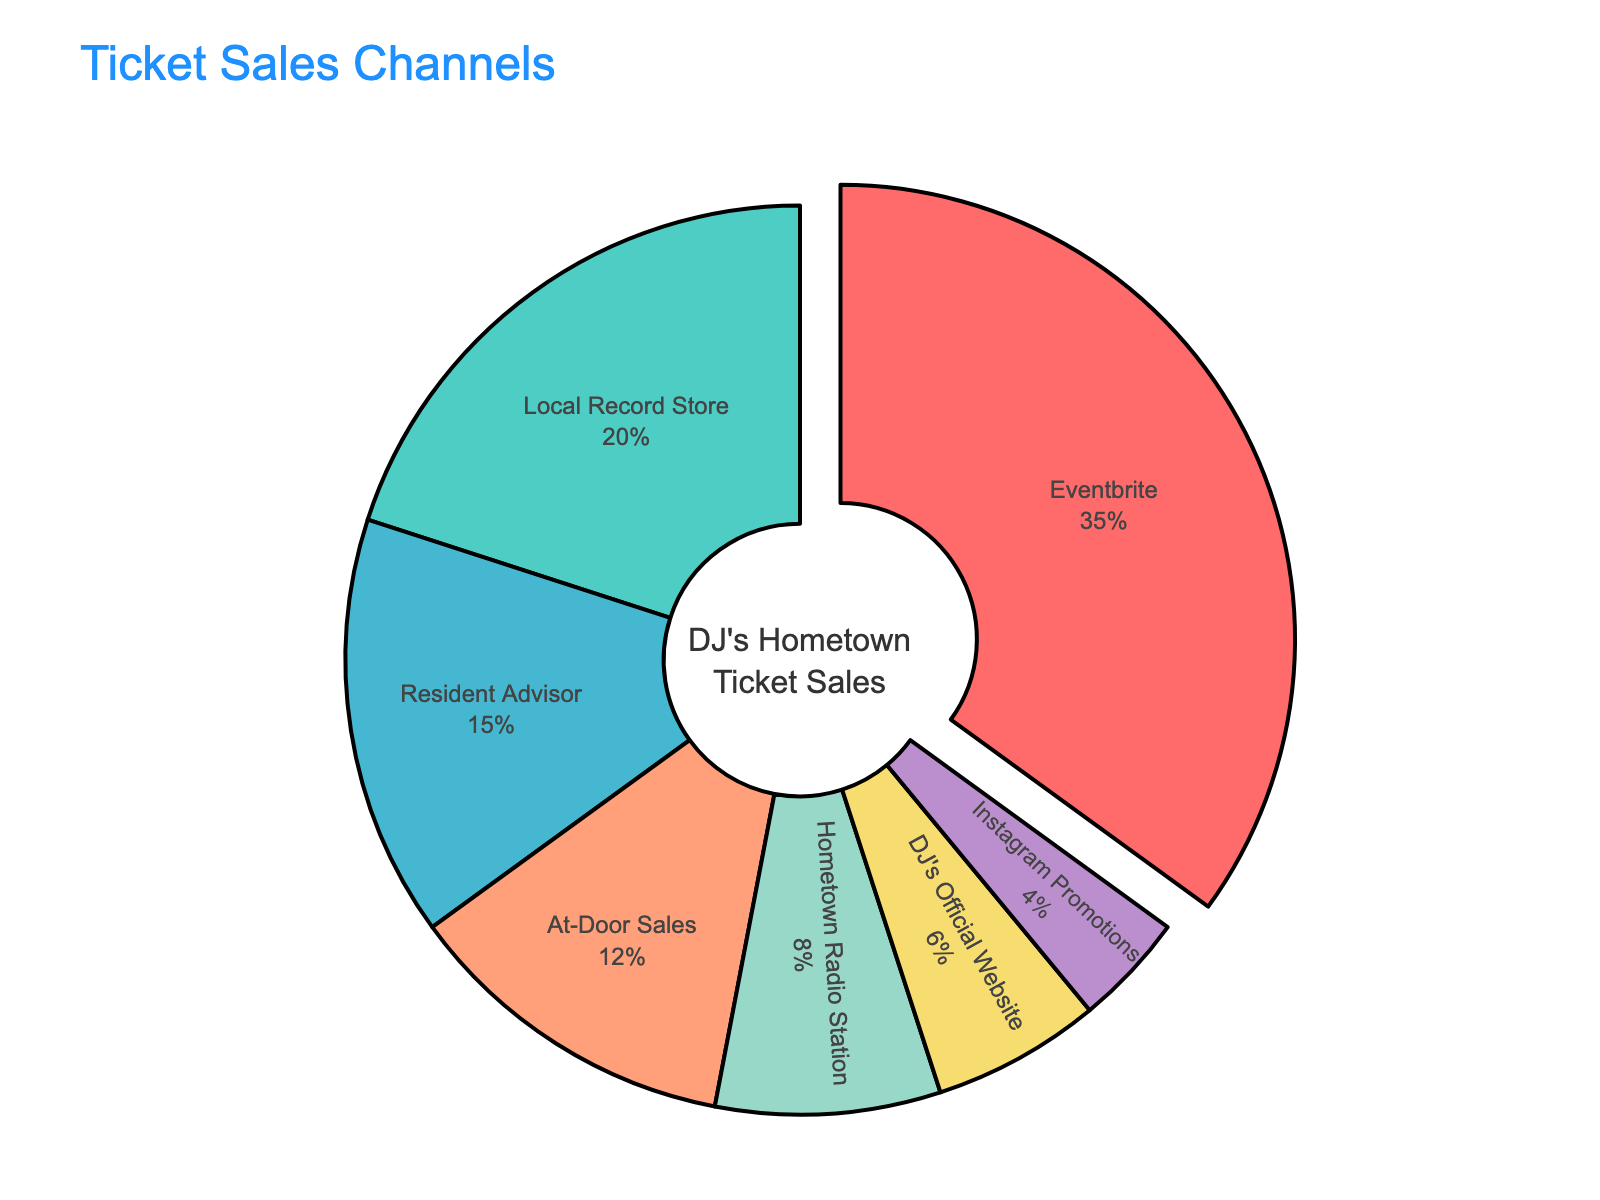What's the most popular ticket sales channel? By looking at the pie chart, the segment representing Eventbrite is the largest, indicating it has the highest percentage of sales.
Answer: Eventbrite What is the combined percentage of ticket sales from Local Record Store and Resident Advisor? The percentage for Local Record Store is 20%, and for Resident Advisor, it is 15%. Adding them together gives 35%.
Answer: 35% Which sales channels have a lower percentage than At-Door Sales? The percentage for At-Door Sales is 12%. The channels with lower percentages are Hometown Radio Station (8%), DJ's Official Website (6%), and Instagram Promotions (4%).
Answer: Hometown Radio Station, DJ's Official Website, Instagram Promotions How much greater is the percentage of sales through Eventbrite compared to Local Record Store? The percentage for Eventbrite is 35%, and for Local Record Store, it is 20%. The difference is 35% - 20% = 15%.
Answer: 15% Rank the sales channels from highest to lowest percentage. The percentages in descending order are: Eventbrite (35%), Local Record Store (20%), Resident Advisor (15%), At-Door Sales (12%), Hometown Radio Station (8%), DJ's Official Website (6%), Instagram Promotions (4%).
Answer: Eventbrite, Local Record Store, Resident Advisor, At-Door Sales, Hometown Radio Station, DJ's Official Website, Instagram Promotions If you combine the percentages of At-Door Sales and Hometown Radio Station, does it exceed the percentage of Local Record Store? The percentages for At-Door Sales (12%) and Hometown Radio Station (8%) add up to 20%, which is equal to the Local Record Store's percentage of 20%.
Answer: No What proportion of the total sales is accounted for by Instagram Promotions compared to Eventbrite? The percentage for Instagram Promotions is 4%, and for Eventbrite, it is 35%. The proportion is 4% / 35% ≈ 0.114, which is approximately 11.4%.
Answer: Approximately 11.4% Which channel's segment is represented with a pullout effect in the pie chart? The pie chart has a segment with a slight pullout effect applied to the Eventbrite segment, indicating it as the most significant sales channel.
Answer: Eventbrite 